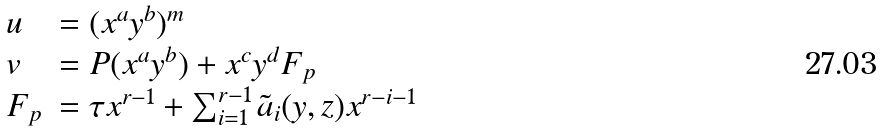Convert formula to latex. <formula><loc_0><loc_0><loc_500><loc_500>\begin{array} { l l } u & = ( x ^ { a } y ^ { b } ) ^ { m } \\ v & = P ( x ^ { a } y ^ { b } ) + x ^ { c } y ^ { d } F _ { p } \\ F _ { p } & = \tau x ^ { r - 1 } + \sum _ { i = 1 } ^ { r - 1 } \tilde { a } _ { i } ( y , z ) x ^ { r - i - 1 } \end{array}</formula> 